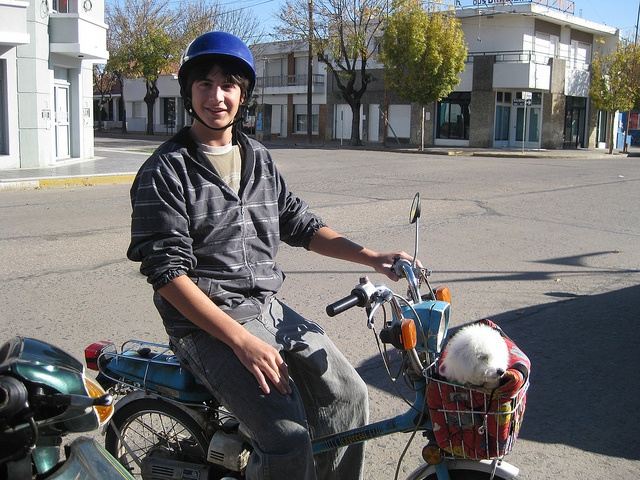Describe the objects in this image and their specific colors. I can see people in white, black, darkgray, gray, and maroon tones, motorcycle in white, black, gray, darkgray, and navy tones, and dog in white, gray, darkgray, and black tones in this image. 